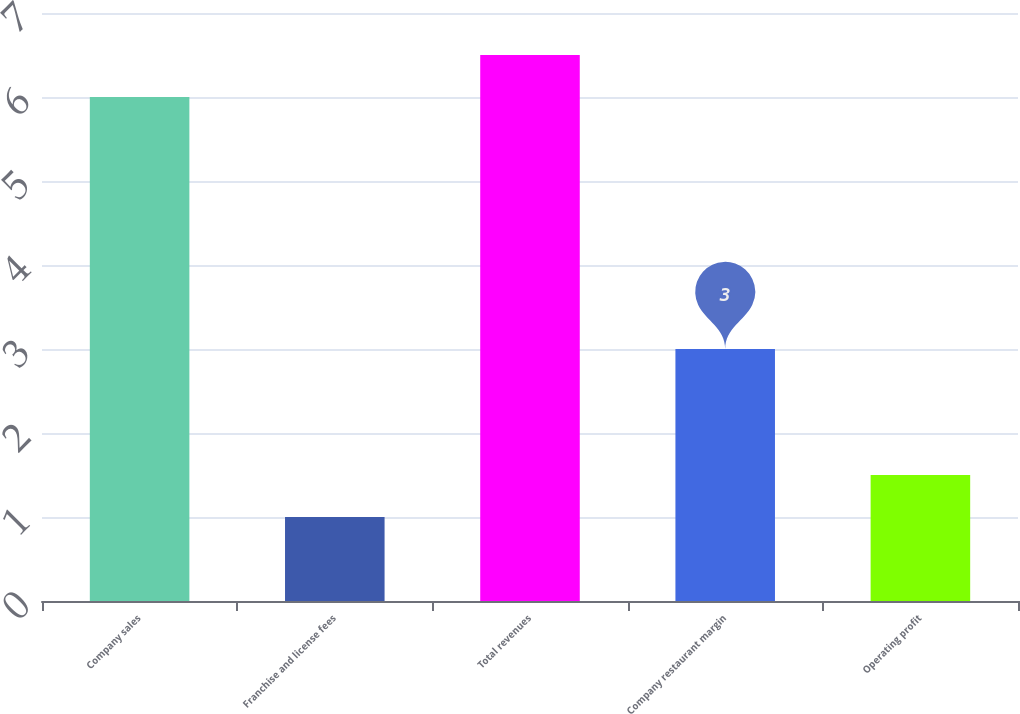<chart> <loc_0><loc_0><loc_500><loc_500><bar_chart><fcel>Company sales<fcel>Franchise and license fees<fcel>Total revenues<fcel>Company restaurant margin<fcel>Operating profit<nl><fcel>6<fcel>1<fcel>6.5<fcel>3<fcel>1.5<nl></chart> 